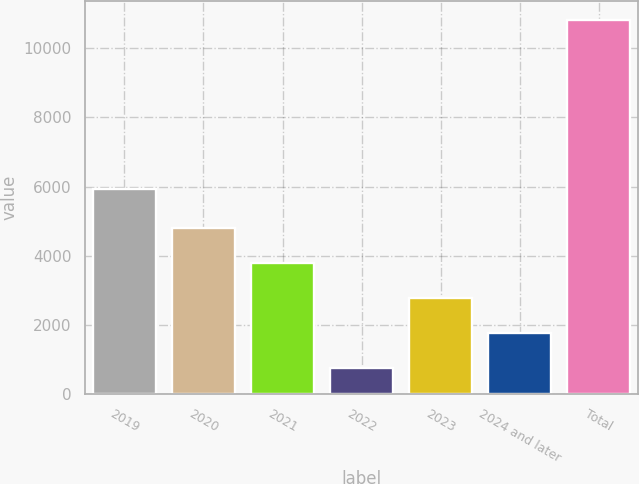Convert chart to OTSL. <chart><loc_0><loc_0><loc_500><loc_500><bar_chart><fcel>2019<fcel>2020<fcel>2021<fcel>2022<fcel>2023<fcel>2024 and later<fcel>Total<nl><fcel>5932<fcel>4785.4<fcel>3777.3<fcel>753<fcel>2769.2<fcel>1761.1<fcel>10834<nl></chart> 